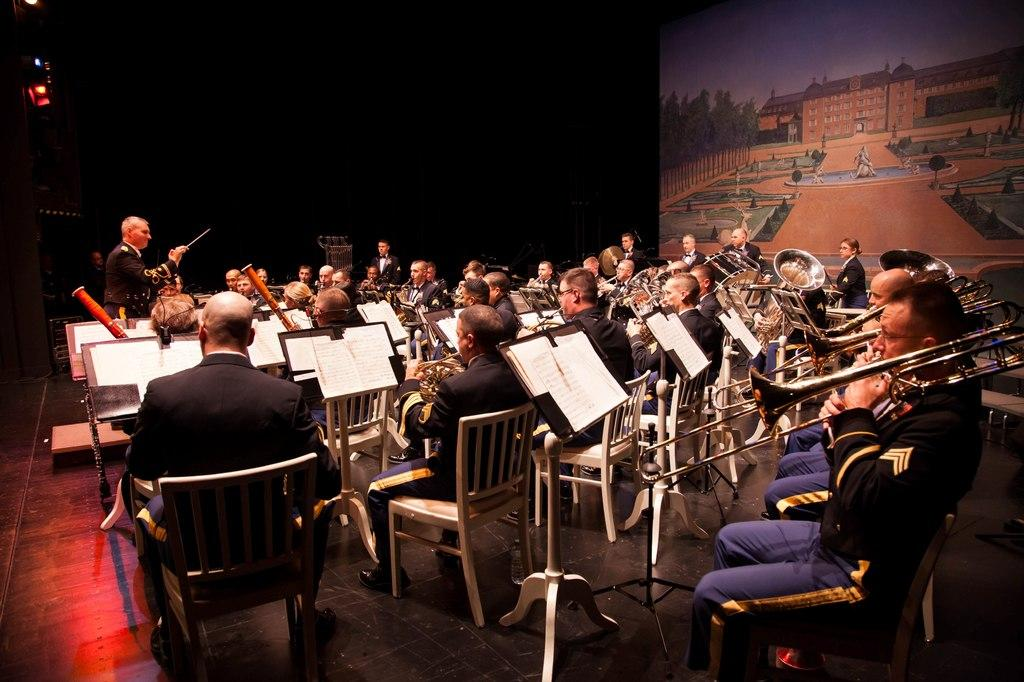Can you describe the abstract scene being discussed? The abstract scene being discussed involves a person who is feeling a sense of need. What emotion is the person experiencing in this scene? The person is experiencing a sense of need. Is there any specific context or situation that might be causing this feeling of need? The provided facts do not specify any context or situation that might be causing this feeling of need. What type of grape is the doctor examining in the image? There is no image provided, and the abstract scene does not involve a doctor examining a grape. 